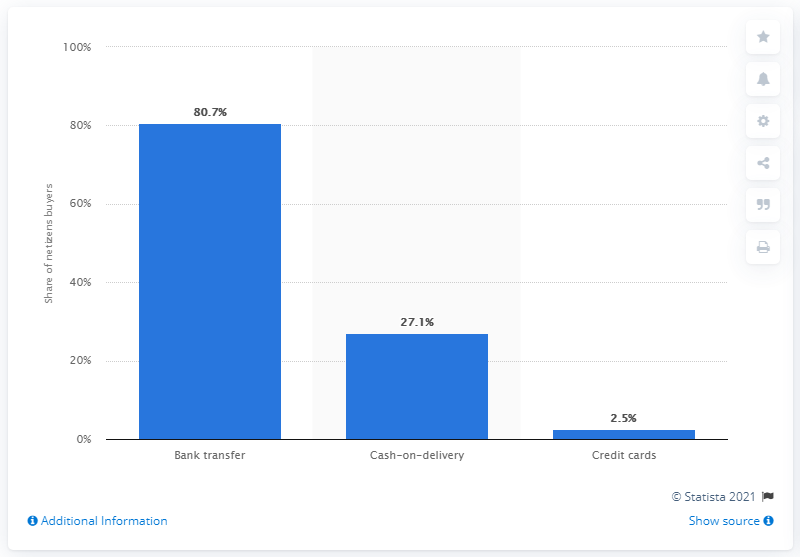Outline some significant characteristics in this image. According to the data, 80.7% of Indonesian netizens paid for their online shopping via bank transfer. 